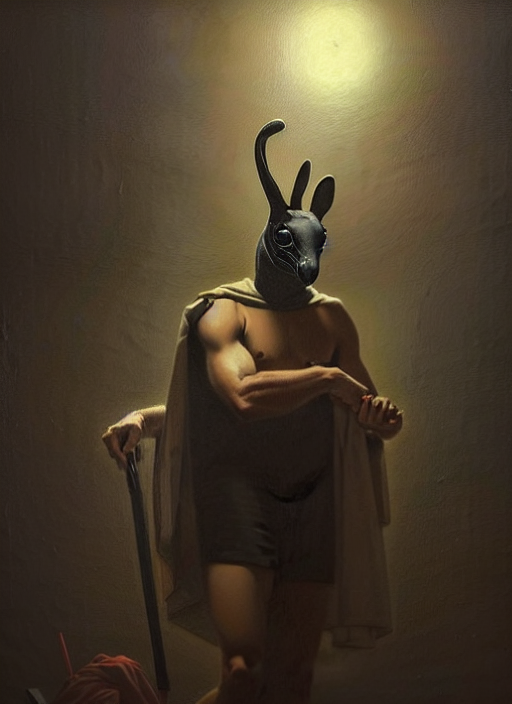Could you describe the symbolism or possible interpretations of the mask worn by the figure? The mask displayed in the image is reminiscent of a rabbit, which might symbolize various things such as fertility, cunning, or vulnerability. In this context, with the figure's muscular form and cloak, it could imply a warrior's guise, wrapping traditional symbolism with a layer of strength and readiness for battle. Given the pose and attire of the figure, what kind of character do you think they represent? The character's pose is one of strength and dominance, with a prominent stance holding onto a staff and draped in a cloak. It suggests a portrayal of a leader or protector with a hidden, perhaps more cunning side, hinted at by the mask. It could be a modern interpretation of a mythic hero or an allegorical figure. 